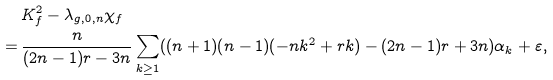<formula> <loc_0><loc_0><loc_500><loc_500>& \, K _ { f } ^ { 2 } - \lambda _ { g , 0 , n } \chi _ { f } \\ = & \, \frac { n } { ( 2 n - 1 ) r - 3 n } \sum _ { k \geq 1 } ( ( n + 1 ) ( n - 1 ) ( - n k ^ { 2 } + r k ) - ( 2 n - 1 ) r + 3 n ) \alpha _ { k } + \varepsilon ,</formula> 